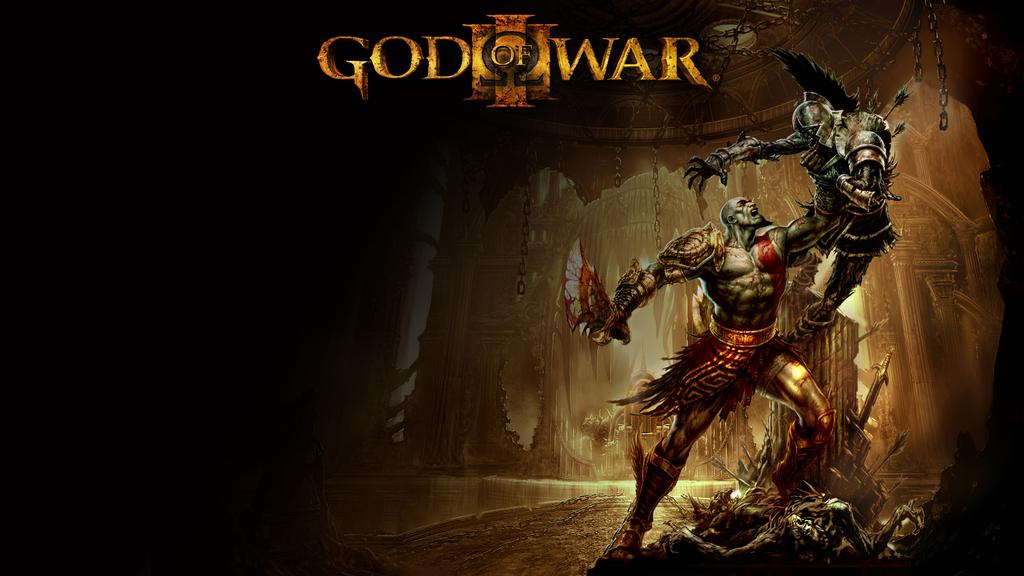Who is this the god of?
Offer a very short reply. War. 